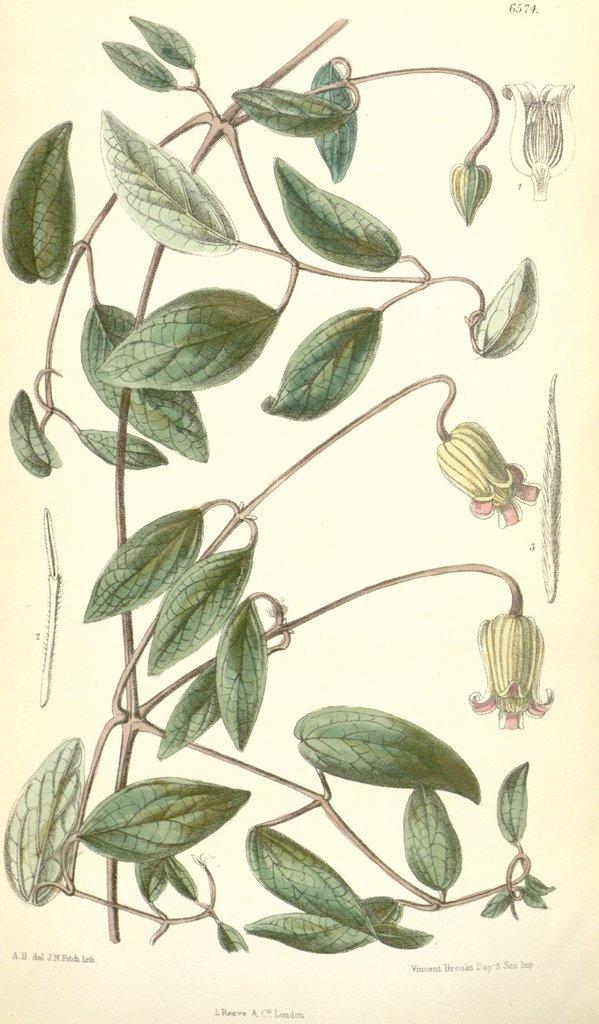How would you summarize this image in a sentence or two? In this image we can see a painting of stems with leaves and flowers. Also there is text on the image. 